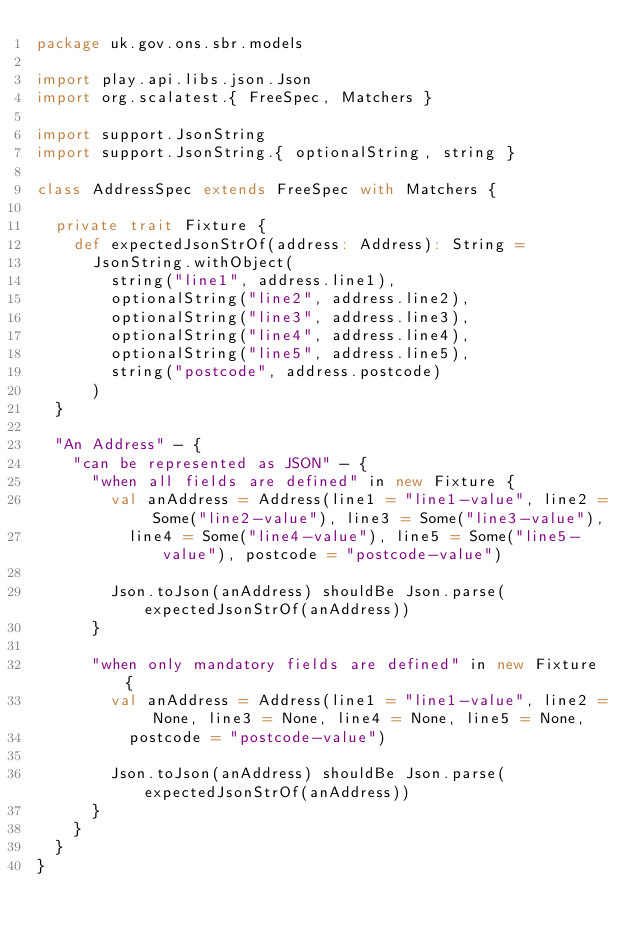Convert code to text. <code><loc_0><loc_0><loc_500><loc_500><_Scala_>package uk.gov.ons.sbr.models

import play.api.libs.json.Json
import org.scalatest.{ FreeSpec, Matchers }

import support.JsonString
import support.JsonString.{ optionalString, string }

class AddressSpec extends FreeSpec with Matchers {

  private trait Fixture {
    def expectedJsonStrOf(address: Address): String =
      JsonString.withObject(
        string("line1", address.line1),
        optionalString("line2", address.line2),
        optionalString("line3", address.line3),
        optionalString("line4", address.line4),
        optionalString("line5", address.line5),
        string("postcode", address.postcode)
      )
  }

  "An Address" - {
    "can be represented as JSON" - {
      "when all fields are defined" in new Fixture {
        val anAddress = Address(line1 = "line1-value", line2 = Some("line2-value"), line3 = Some("line3-value"),
          line4 = Some("line4-value"), line5 = Some("line5-value"), postcode = "postcode-value")

        Json.toJson(anAddress) shouldBe Json.parse(expectedJsonStrOf(anAddress))
      }

      "when only mandatory fields are defined" in new Fixture {
        val anAddress = Address(line1 = "line1-value", line2 = None, line3 = None, line4 = None, line5 = None,
          postcode = "postcode-value")

        Json.toJson(anAddress) shouldBe Json.parse(expectedJsonStrOf(anAddress))
      }
    }
  }
}
</code> 